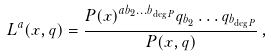<formula> <loc_0><loc_0><loc_500><loc_500>L ^ { a } ( x , q ) = \frac { P ( x ) ^ { a b _ { 2 } \dots b _ { \deg P } } q _ { b _ { 2 } } \dots q _ { b _ { \deg P } } } { P ( x , q ) } \, ,</formula> 